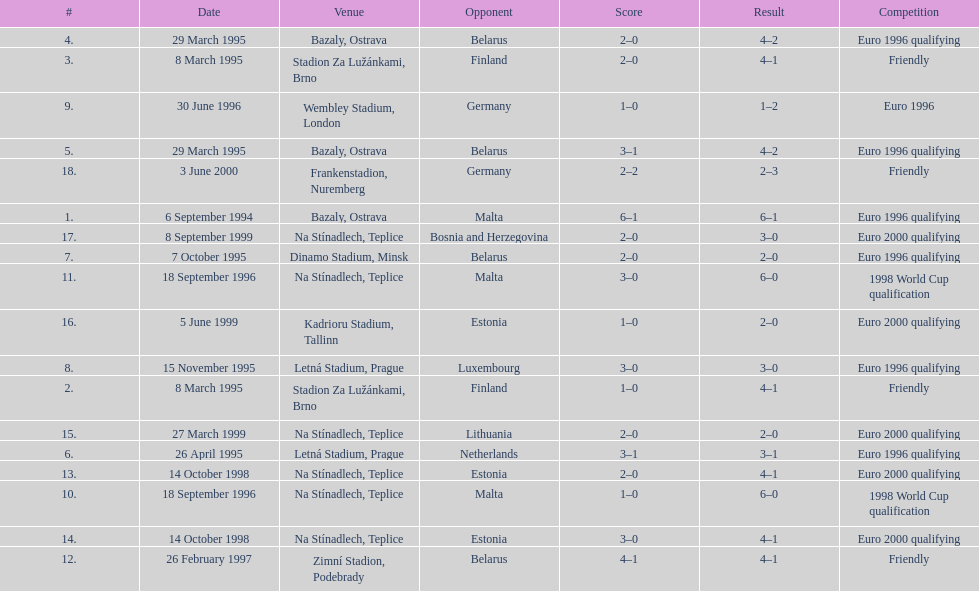List the opponents which are under the friendly competition. Finland, Belarus, Germany. 